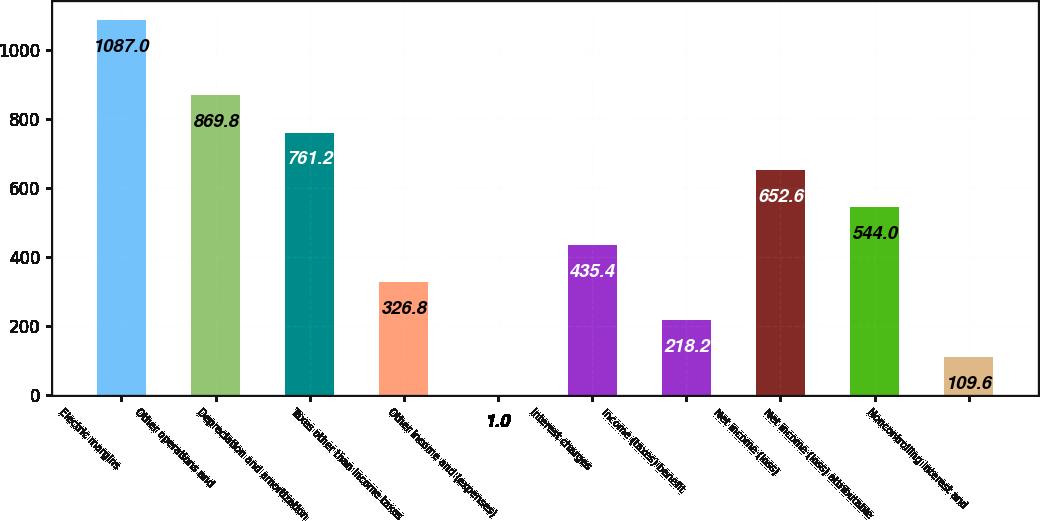Convert chart. <chart><loc_0><loc_0><loc_500><loc_500><bar_chart><fcel>Electric margins<fcel>Other operations and<fcel>Depreciation and amortization<fcel>Taxes other than income taxes<fcel>Other income and (expenses)<fcel>Interest charges<fcel>Income (taxes) benefit<fcel>Net income (loss)<fcel>Net income (loss) attributable<fcel>Noncontrolling interest and<nl><fcel>1087<fcel>869.8<fcel>761.2<fcel>326.8<fcel>1<fcel>435.4<fcel>218.2<fcel>652.6<fcel>544<fcel>109.6<nl></chart> 